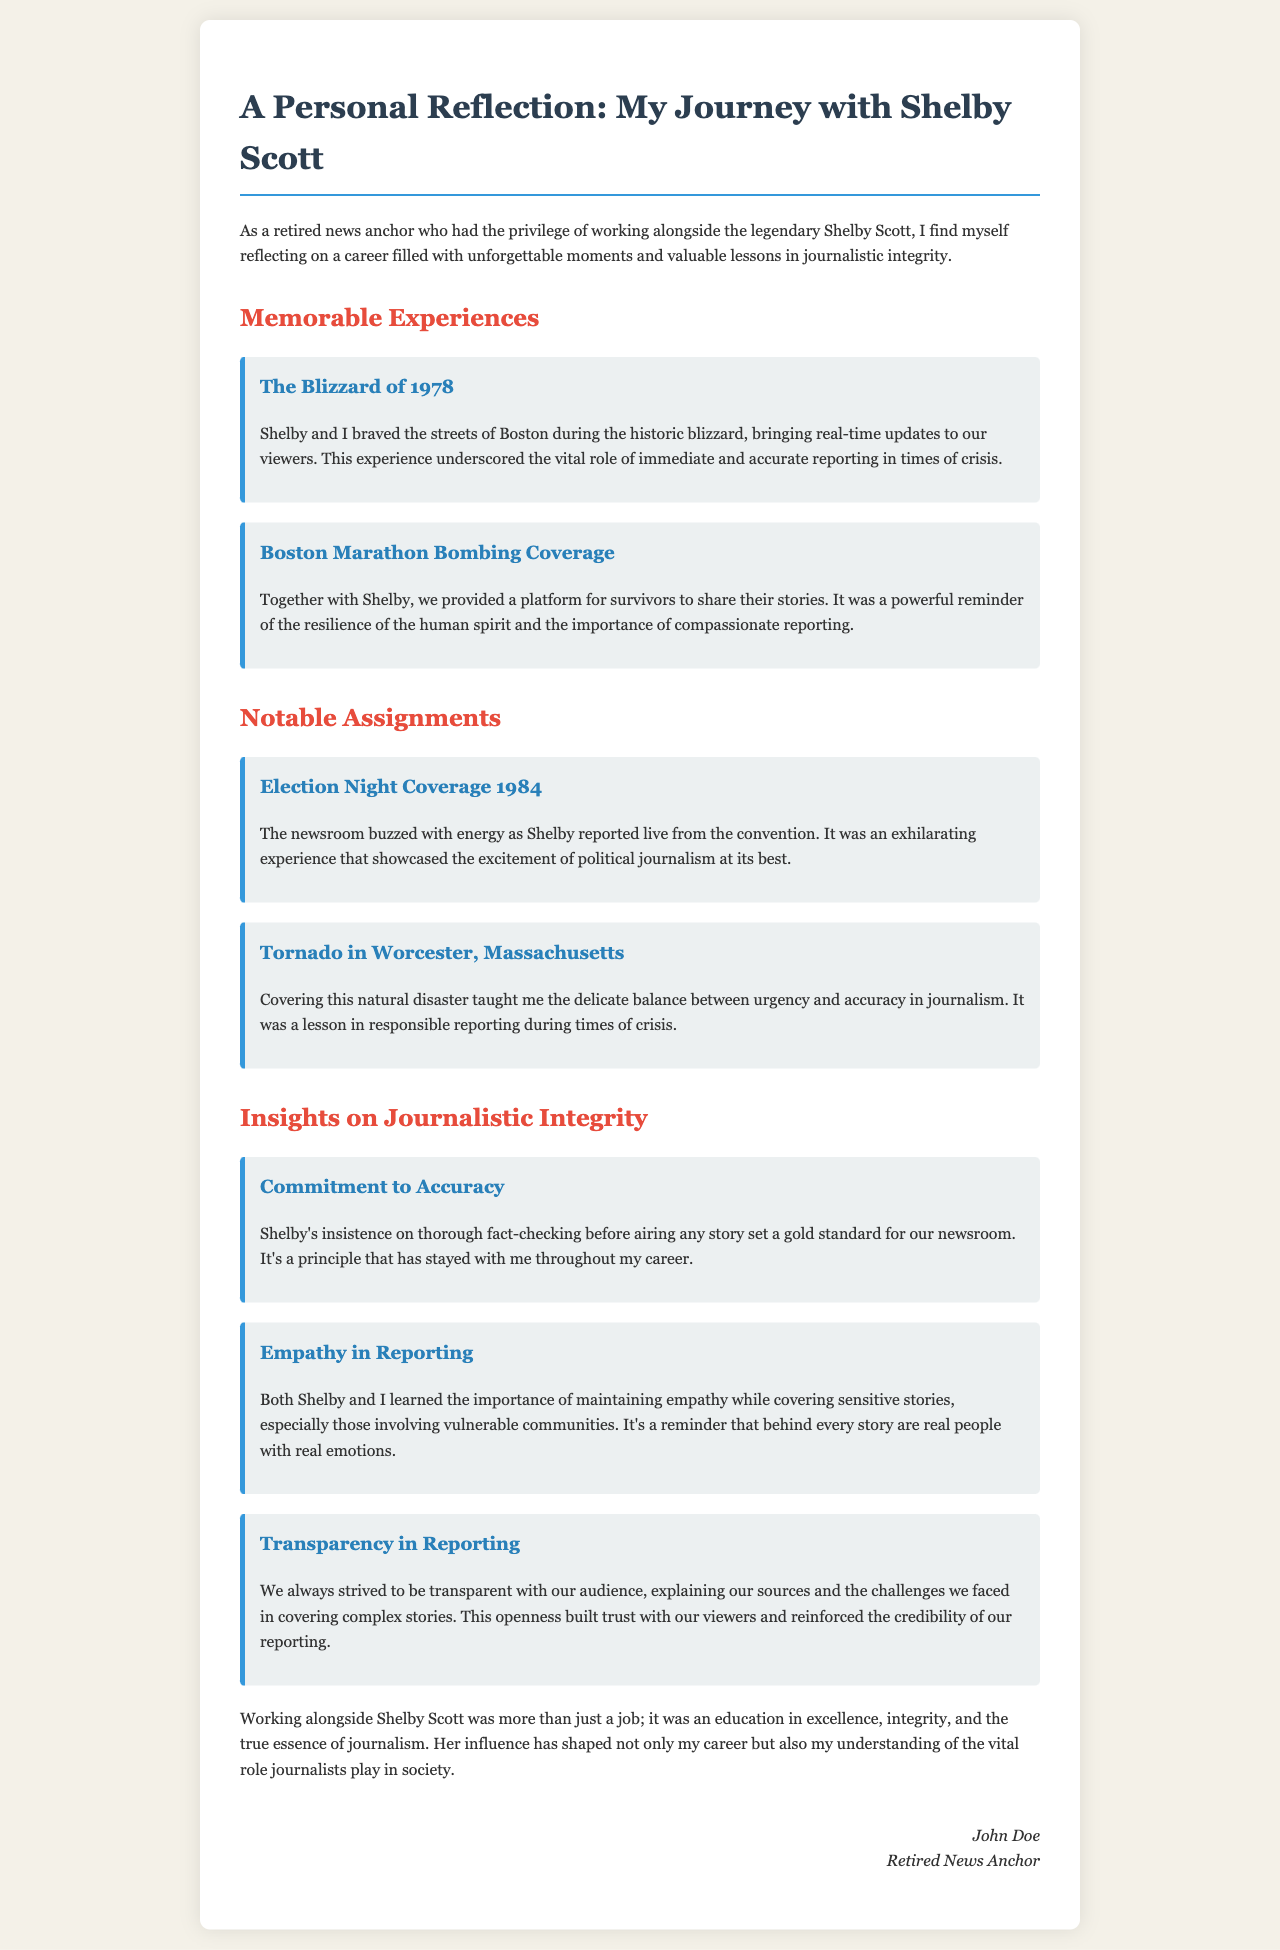What notable event did the author cover with Shelby Scott? The author recounts covering the historic blizzard as a memorable event experienced alongside Shelby Scott.
Answer: The Blizzard of 1978 What does the author emphasize about reporting during the Boston Marathon Bombing? The author mentions providing a platform for survivors and the importance of compassionate reporting during this assignment.
Answer: Compassionate reporting Which election night is mentioned in the document? The author includes coverage details of the election night that took place in 1984.
Answer: 1984 What lesson did the author learn from covering the tornado in Worcester? The document states that the experience taught the author about balancing urgency and accuracy in journalism.
Answer: Balance between urgency and accuracy What is one of the author's insights on journalistic integrity regarding fact-checking? The author highlights Shelby's practice of thorough fact-checking before airing stories, which set a standard in their newsroom.
Answer: Commitment to accuracy How did the author describe empathy in reporting? The author reflects on the necessity of empathy while covering sensitive stories involving vulnerable communities.
Answer: Importance of maintaining empathy What principle regarding audience interaction did the authors strive for? The emphasis in the document is on transparency with the audience about sources and reporting challenges.
Answer: Transparency in reporting Who is the author of the letter? The document specifies the author's name at the end, identifying him as a retired news anchor.
Answer: John Doe 